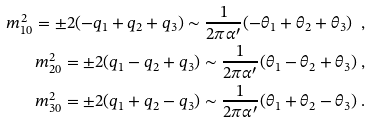Convert formula to latex. <formula><loc_0><loc_0><loc_500><loc_500>m _ { 1 0 } ^ { 2 } = \pm 2 ( - q _ { 1 } + q _ { 2 } + q _ { 3 } ) \sim \frac { 1 } { 2 \pi \alpha ^ { \prime } } ( - \theta _ { 1 } + \theta _ { 2 } + \theta _ { 3 } ) \ , \\ m _ { 2 0 } ^ { 2 } = \pm 2 ( q _ { 1 } - q _ { 2 } + q _ { 3 } ) \sim \frac { 1 } { 2 \pi \alpha ^ { \prime } } ( \theta _ { 1 } - \theta _ { 2 } + \theta _ { 3 } ) \ , \\ m _ { 3 0 } ^ { 2 } = \pm 2 ( q _ { 1 } + q _ { 2 } - q _ { 3 } ) \sim \frac { 1 } { 2 \pi \alpha ^ { \prime } } ( \theta _ { 1 } + \theta _ { 2 } - \theta _ { 3 } ) \ .</formula> 